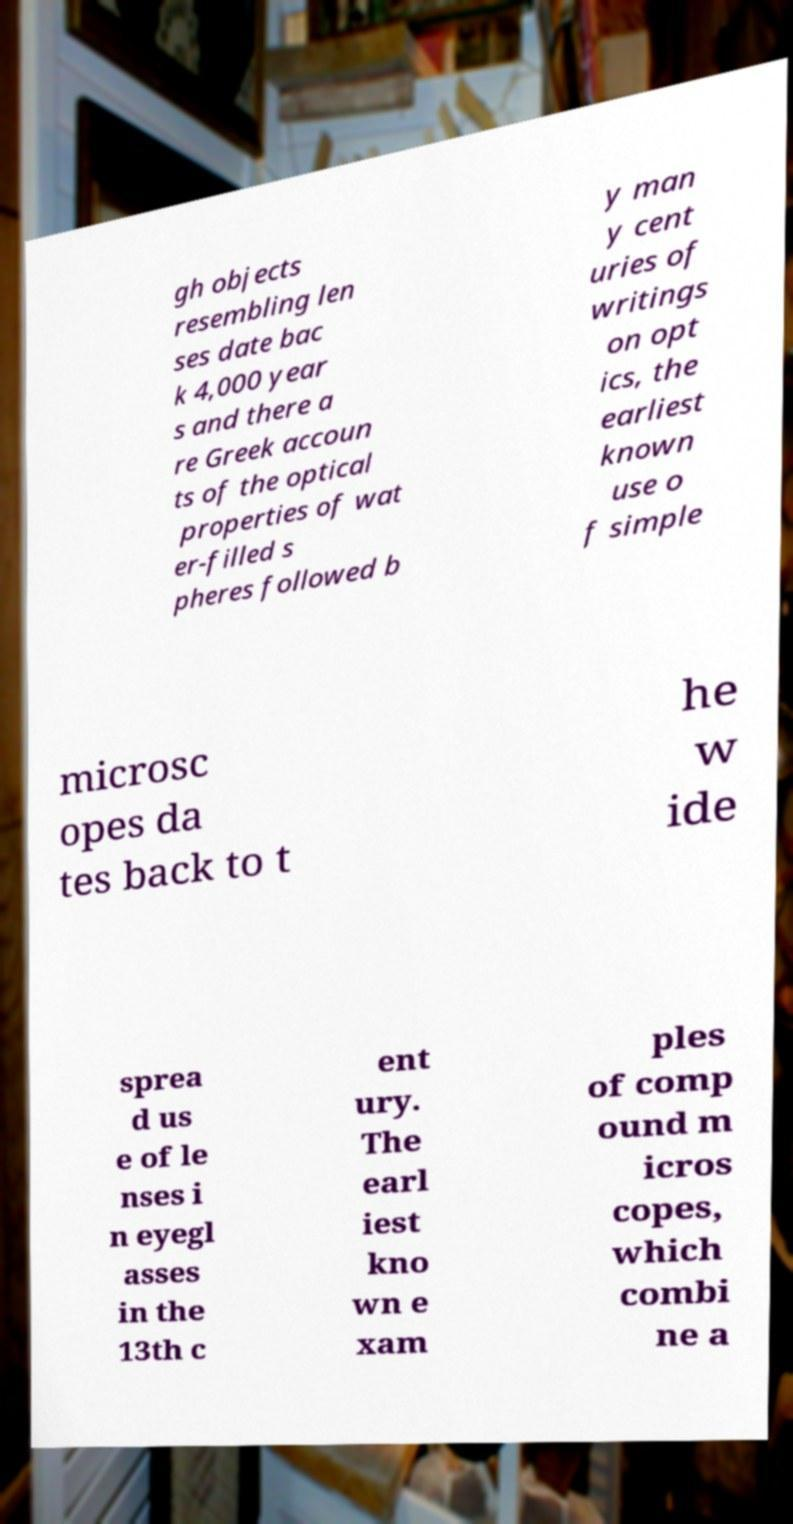There's text embedded in this image that I need extracted. Can you transcribe it verbatim? gh objects resembling len ses date bac k 4,000 year s and there a re Greek accoun ts of the optical properties of wat er-filled s pheres followed b y man y cent uries of writings on opt ics, the earliest known use o f simple microsc opes da tes back to t he w ide sprea d us e of le nses i n eyegl asses in the 13th c ent ury. The earl iest kno wn e xam ples of comp ound m icros copes, which combi ne a 